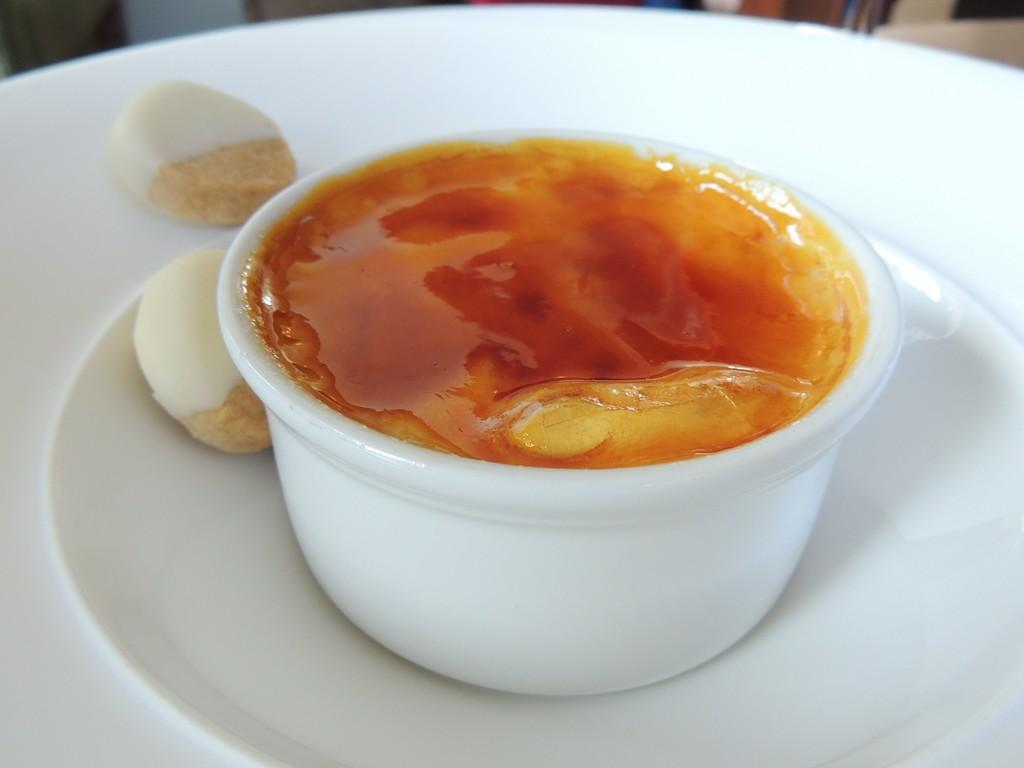What is inside the box that is visible in the image? There are food places in a box. Where is the box located in the image? The box is on a plate. What color is the plate? The plate is white. How does the sleet affect the range of the food places in the image? There is no sleet present in the image, and therefore no effect on the range of the food places can be observed. 